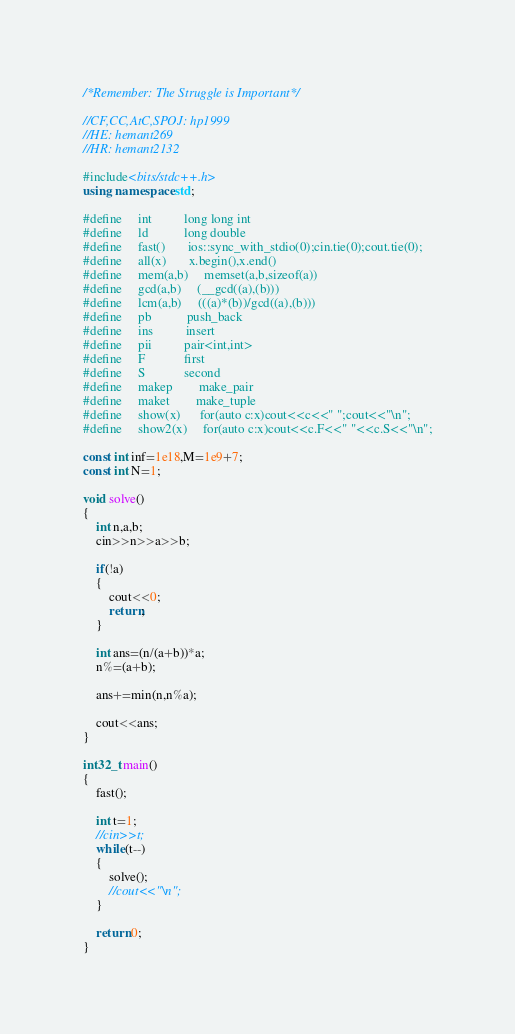Convert code to text. <code><loc_0><loc_0><loc_500><loc_500><_C++_>/*Remember: The Struggle is Important*/

//CF,CC,AtC,SPOJ: hp1999
//HE: hemant269
//HR: hemant2132

#include<bits/stdc++.h>
using namespace std;

#define     int          long long int
#define     ld           long double
#define     fast()       ios::sync_with_stdio(0);cin.tie(0);cout.tie(0);
#define     all(x)       x.begin(),x.end()
#define     mem(a,b)     memset(a,b,sizeof(a))
#define     gcd(a,b)     (__gcd((a),(b)))
#define     lcm(a,b)     (((a)*(b))/gcd((a),(b)))
#define     pb           push_back
#define     ins          insert
#define     pii          pair<int,int>
#define     F            first
#define     S            second
#define     makep        make_pair
#define     maket        make_tuple
#define     show(x)      for(auto c:x)cout<<c<<" ";cout<<"\n";
#define     show2(x)     for(auto c:x)cout<<c.F<<" "<<c.S<<"\n";

const int inf=1e18,M=1e9+7;
const int N=1;

void solve()
{
    int n,a,b;
    cin>>n>>a>>b;

    if(!a)
    {
        cout<<0;
        return;
    }

    int ans=(n/(a+b))*a;
    n%=(a+b);

    ans+=min(n,n%a);

    cout<<ans;
}

int32_t main()
{
    fast();

    int t=1;
    //cin>>t;
    while(t--)
    {
        solve();
        //cout<<"\n";
    }

    return 0;
}


</code> 